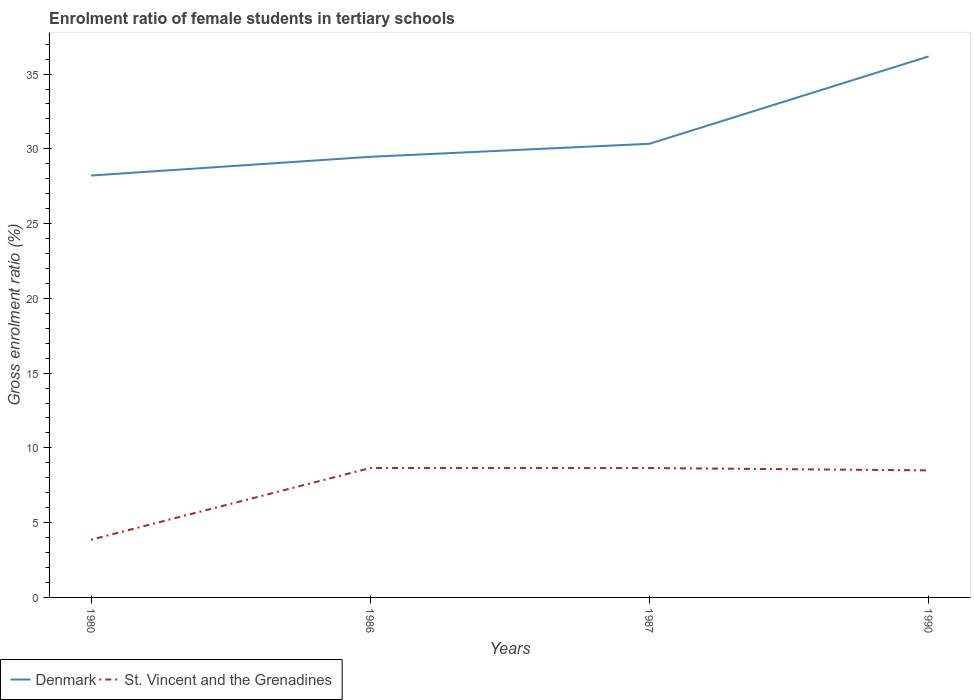Across all years, what is the maximum enrolment ratio of female students in tertiary schools in St. Vincent and the Grenadines?
Offer a very short reply. 3.86. In which year was the enrolment ratio of female students in tertiary schools in Denmark maximum?
Offer a very short reply. 1980. What is the total enrolment ratio of female students in tertiary schools in St. Vincent and the Grenadines in the graph?
Keep it short and to the point. -4.79. What is the difference between the highest and the second highest enrolment ratio of female students in tertiary schools in St. Vincent and the Grenadines?
Make the answer very short. 4.79. What is the difference between two consecutive major ticks on the Y-axis?
Provide a short and direct response. 5. Does the graph contain any zero values?
Keep it short and to the point. No. What is the title of the graph?
Ensure brevity in your answer.  Enrolment ratio of female students in tertiary schools. Does "Zimbabwe" appear as one of the legend labels in the graph?
Offer a terse response. No. What is the label or title of the Y-axis?
Your response must be concise. Gross enrolment ratio (%). What is the Gross enrolment ratio (%) in Denmark in 1980?
Your response must be concise. 28.22. What is the Gross enrolment ratio (%) in St. Vincent and the Grenadines in 1980?
Give a very brief answer. 3.86. What is the Gross enrolment ratio (%) in Denmark in 1986?
Keep it short and to the point. 29.47. What is the Gross enrolment ratio (%) in St. Vincent and the Grenadines in 1986?
Make the answer very short. 8.65. What is the Gross enrolment ratio (%) of Denmark in 1987?
Make the answer very short. 30.34. What is the Gross enrolment ratio (%) of St. Vincent and the Grenadines in 1987?
Your answer should be very brief. 8.65. What is the Gross enrolment ratio (%) of Denmark in 1990?
Ensure brevity in your answer.  36.18. What is the Gross enrolment ratio (%) of St. Vincent and the Grenadines in 1990?
Offer a very short reply. 8.5. Across all years, what is the maximum Gross enrolment ratio (%) in Denmark?
Provide a short and direct response. 36.18. Across all years, what is the maximum Gross enrolment ratio (%) in St. Vincent and the Grenadines?
Keep it short and to the point. 8.65. Across all years, what is the minimum Gross enrolment ratio (%) of Denmark?
Make the answer very short. 28.22. Across all years, what is the minimum Gross enrolment ratio (%) in St. Vincent and the Grenadines?
Your answer should be very brief. 3.86. What is the total Gross enrolment ratio (%) of Denmark in the graph?
Provide a short and direct response. 124.2. What is the total Gross enrolment ratio (%) in St. Vincent and the Grenadines in the graph?
Provide a short and direct response. 29.66. What is the difference between the Gross enrolment ratio (%) of Denmark in 1980 and that in 1986?
Offer a very short reply. -1.25. What is the difference between the Gross enrolment ratio (%) in St. Vincent and the Grenadines in 1980 and that in 1986?
Make the answer very short. -4.79. What is the difference between the Gross enrolment ratio (%) of Denmark in 1980 and that in 1987?
Ensure brevity in your answer.  -2.12. What is the difference between the Gross enrolment ratio (%) of St. Vincent and the Grenadines in 1980 and that in 1987?
Provide a succinct answer. -4.79. What is the difference between the Gross enrolment ratio (%) in Denmark in 1980 and that in 1990?
Ensure brevity in your answer.  -7.97. What is the difference between the Gross enrolment ratio (%) of St. Vincent and the Grenadines in 1980 and that in 1990?
Provide a succinct answer. -4.64. What is the difference between the Gross enrolment ratio (%) in Denmark in 1986 and that in 1987?
Keep it short and to the point. -0.87. What is the difference between the Gross enrolment ratio (%) in St. Vincent and the Grenadines in 1986 and that in 1987?
Ensure brevity in your answer.  0. What is the difference between the Gross enrolment ratio (%) of Denmark in 1986 and that in 1990?
Offer a very short reply. -6.71. What is the difference between the Gross enrolment ratio (%) in St. Vincent and the Grenadines in 1986 and that in 1990?
Offer a terse response. 0.15. What is the difference between the Gross enrolment ratio (%) in Denmark in 1987 and that in 1990?
Provide a succinct answer. -5.84. What is the difference between the Gross enrolment ratio (%) of St. Vincent and the Grenadines in 1987 and that in 1990?
Make the answer very short. 0.15. What is the difference between the Gross enrolment ratio (%) in Denmark in 1980 and the Gross enrolment ratio (%) in St. Vincent and the Grenadines in 1986?
Make the answer very short. 19.56. What is the difference between the Gross enrolment ratio (%) in Denmark in 1980 and the Gross enrolment ratio (%) in St. Vincent and the Grenadines in 1987?
Your answer should be very brief. 19.56. What is the difference between the Gross enrolment ratio (%) of Denmark in 1980 and the Gross enrolment ratio (%) of St. Vincent and the Grenadines in 1990?
Your answer should be very brief. 19.72. What is the difference between the Gross enrolment ratio (%) of Denmark in 1986 and the Gross enrolment ratio (%) of St. Vincent and the Grenadines in 1987?
Provide a short and direct response. 20.82. What is the difference between the Gross enrolment ratio (%) of Denmark in 1986 and the Gross enrolment ratio (%) of St. Vincent and the Grenadines in 1990?
Offer a very short reply. 20.97. What is the difference between the Gross enrolment ratio (%) of Denmark in 1987 and the Gross enrolment ratio (%) of St. Vincent and the Grenadines in 1990?
Ensure brevity in your answer.  21.84. What is the average Gross enrolment ratio (%) of Denmark per year?
Your response must be concise. 31.05. What is the average Gross enrolment ratio (%) of St. Vincent and the Grenadines per year?
Your response must be concise. 7.42. In the year 1980, what is the difference between the Gross enrolment ratio (%) in Denmark and Gross enrolment ratio (%) in St. Vincent and the Grenadines?
Keep it short and to the point. 24.35. In the year 1986, what is the difference between the Gross enrolment ratio (%) of Denmark and Gross enrolment ratio (%) of St. Vincent and the Grenadines?
Offer a terse response. 20.81. In the year 1987, what is the difference between the Gross enrolment ratio (%) of Denmark and Gross enrolment ratio (%) of St. Vincent and the Grenadines?
Offer a terse response. 21.69. In the year 1990, what is the difference between the Gross enrolment ratio (%) in Denmark and Gross enrolment ratio (%) in St. Vincent and the Grenadines?
Provide a short and direct response. 27.68. What is the ratio of the Gross enrolment ratio (%) in Denmark in 1980 to that in 1986?
Your answer should be very brief. 0.96. What is the ratio of the Gross enrolment ratio (%) of St. Vincent and the Grenadines in 1980 to that in 1986?
Keep it short and to the point. 0.45. What is the ratio of the Gross enrolment ratio (%) in Denmark in 1980 to that in 1987?
Offer a very short reply. 0.93. What is the ratio of the Gross enrolment ratio (%) of St. Vincent and the Grenadines in 1980 to that in 1987?
Your response must be concise. 0.45. What is the ratio of the Gross enrolment ratio (%) of Denmark in 1980 to that in 1990?
Make the answer very short. 0.78. What is the ratio of the Gross enrolment ratio (%) of St. Vincent and the Grenadines in 1980 to that in 1990?
Provide a succinct answer. 0.45. What is the ratio of the Gross enrolment ratio (%) in Denmark in 1986 to that in 1987?
Offer a terse response. 0.97. What is the ratio of the Gross enrolment ratio (%) of Denmark in 1986 to that in 1990?
Ensure brevity in your answer.  0.81. What is the ratio of the Gross enrolment ratio (%) of St. Vincent and the Grenadines in 1986 to that in 1990?
Keep it short and to the point. 1.02. What is the ratio of the Gross enrolment ratio (%) in Denmark in 1987 to that in 1990?
Ensure brevity in your answer.  0.84. What is the ratio of the Gross enrolment ratio (%) in St. Vincent and the Grenadines in 1987 to that in 1990?
Offer a terse response. 1.02. What is the difference between the highest and the second highest Gross enrolment ratio (%) in Denmark?
Your answer should be compact. 5.84. What is the difference between the highest and the second highest Gross enrolment ratio (%) in St. Vincent and the Grenadines?
Your answer should be very brief. 0. What is the difference between the highest and the lowest Gross enrolment ratio (%) in Denmark?
Ensure brevity in your answer.  7.97. What is the difference between the highest and the lowest Gross enrolment ratio (%) in St. Vincent and the Grenadines?
Offer a very short reply. 4.79. 